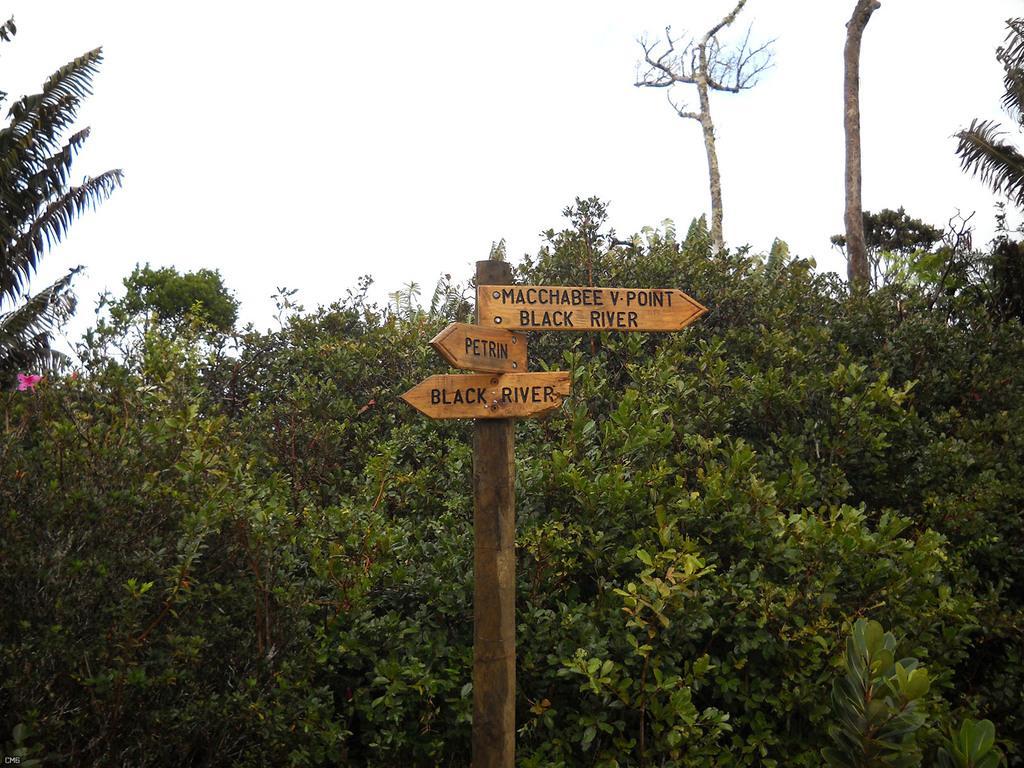Please provide a concise description of this image. In this image there is the sky towards the top of the image, there are trees, there is a flower on the tree, there is a wooden pole towards the bottom of the image, there are wooden boards on the pole, there is text on the wooden boards. 